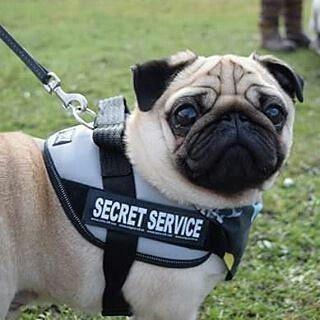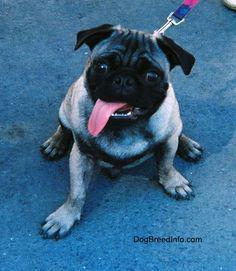The first image is the image on the left, the second image is the image on the right. Examine the images to the left and right. Is the description "Some dogs are riding a carnival ride." accurate? Answer yes or no. No. The first image is the image on the left, the second image is the image on the right. Given the left and right images, does the statement "Three beige pugs with dark muzzles are sitting in a row inside a red and blue car, and the middle dog has one paw on the steering wheel." hold true? Answer yes or no. No. 